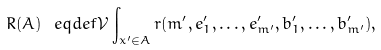Convert formula to latex. <formula><loc_0><loc_0><loc_500><loc_500>R ( A ) \ e q d e f { \mathcal { V } } \int _ { x ^ { \prime } \in A } r ( m ^ { \prime } , e ^ { \prime } _ { 1 } , \dots , e ^ { \prime } _ { m ^ { \prime } } , b ^ { \prime } _ { 1 } , \dots , b ^ { \prime } _ { m ^ { \prime } } ) ,</formula> 